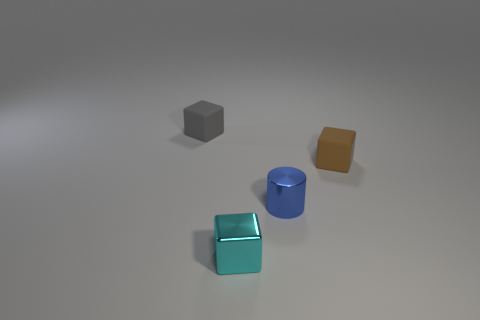There is a tiny block that is in front of the metallic thing that is behind the tiny metal block; what is its material?
Give a very brief answer. Metal. What shape is the gray thing that is the same size as the brown rubber cube?
Provide a succinct answer. Cube. Is the number of blue cylinders less than the number of tiny metal things?
Keep it short and to the point. Yes. There is a shiny object that is behind the cyan metal object; are there any tiny blue metal things that are on the right side of it?
Your response must be concise. No. What shape is the other small object that is the same material as the blue thing?
Your answer should be compact. Cube. Is there any other thing that has the same color as the metallic cube?
Ensure brevity in your answer.  No. What is the material of the cyan object that is the same shape as the small gray thing?
Keep it short and to the point. Metal. Is the shape of the tiny thing in front of the tiny cylinder the same as  the blue thing?
Your response must be concise. No. What number of other things are there of the same shape as the small blue thing?
Ensure brevity in your answer.  0. What is the shape of the object in front of the small blue object?
Your response must be concise. Cube. 